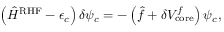<formula> <loc_0><loc_0><loc_500><loc_500>\left ( \hat { H } ^ { R H F } - \epsilon _ { c } \right ) \delta \psi _ { c } = - \left ( \hat { f } + \delta V _ { c o r e } ^ { f } \right ) \psi _ { c } ,</formula> 